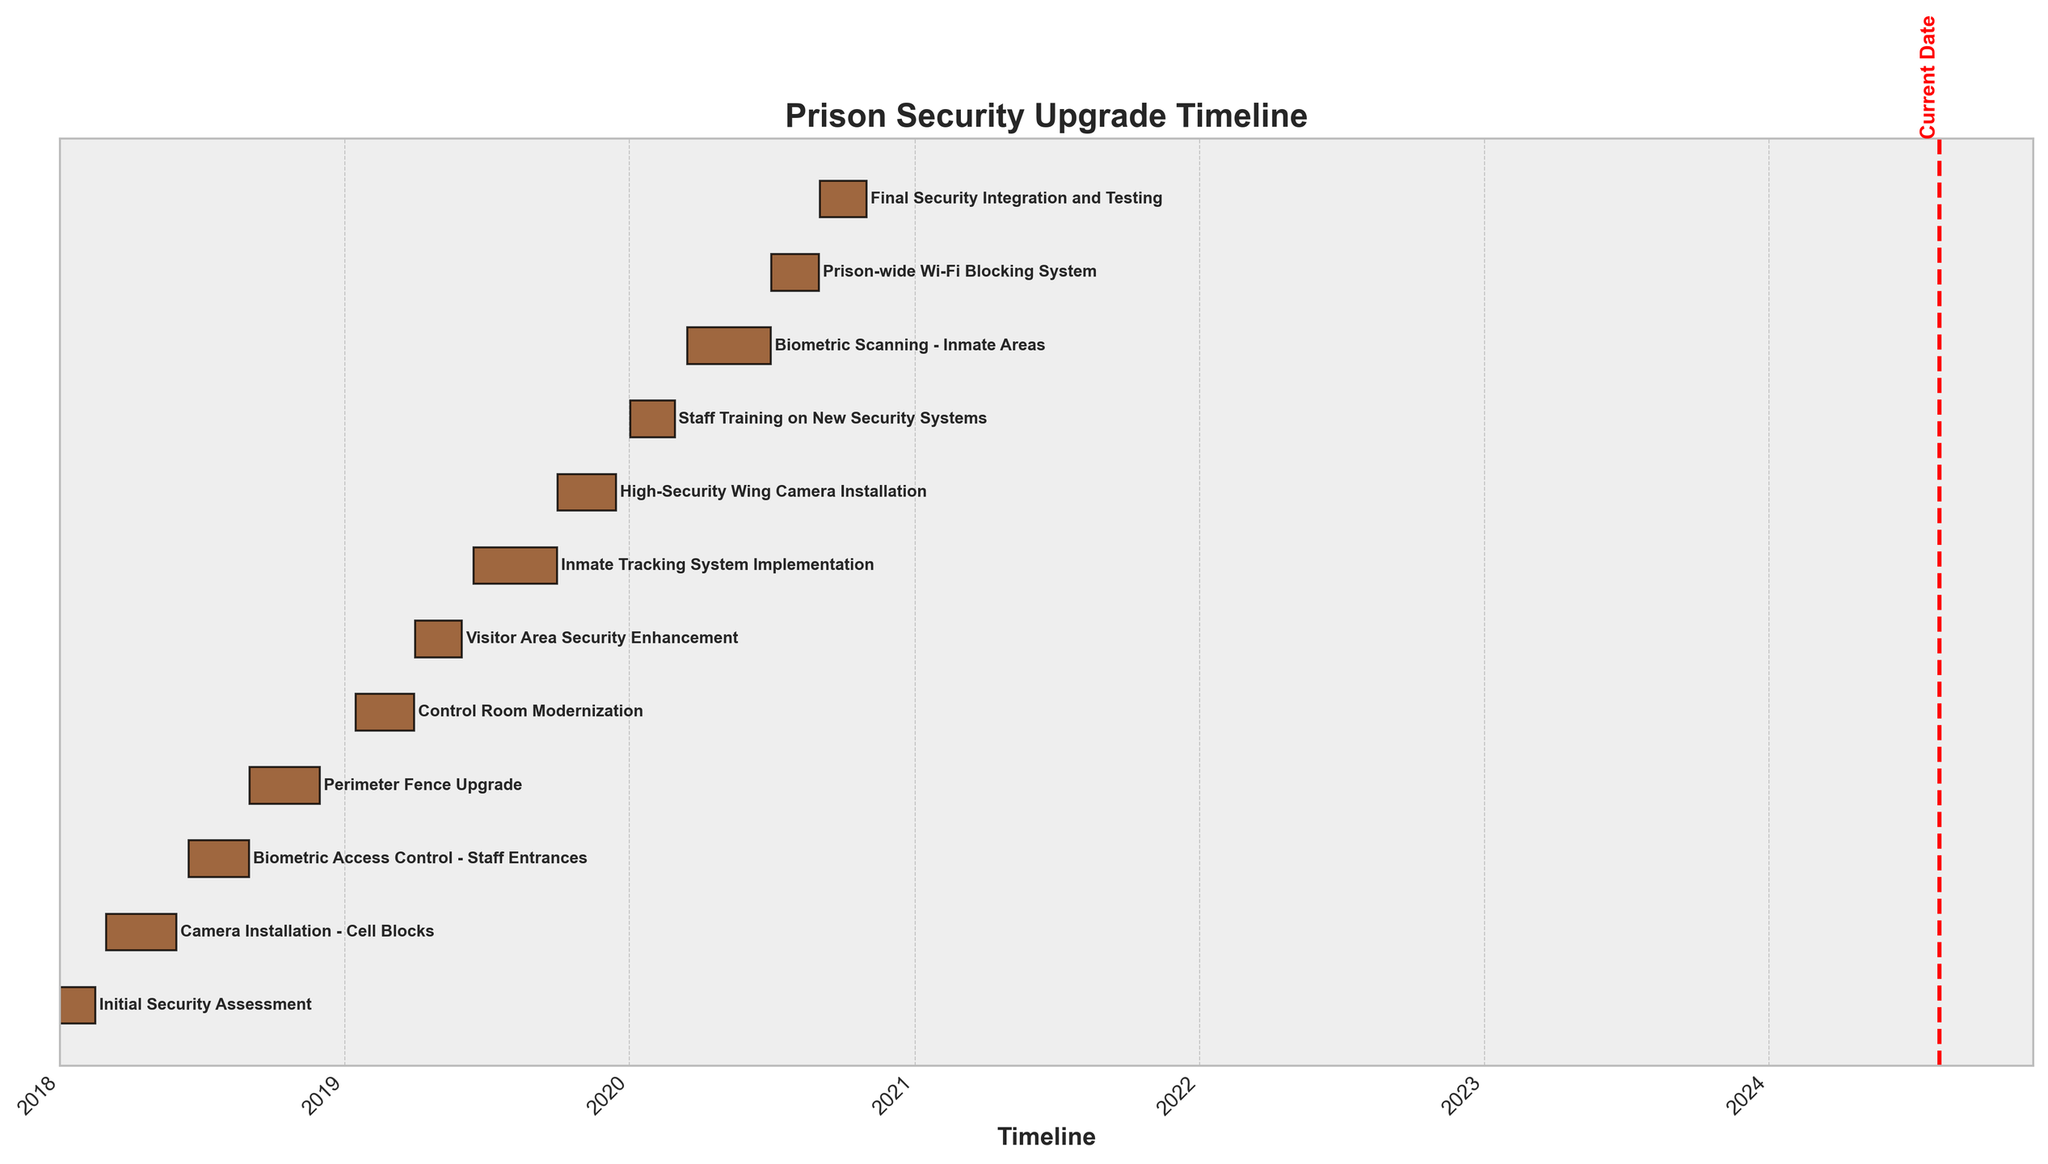What is the title of the chart? The title of the chart appears at the top and indicates the main subject of the visualized data.
Answer: Prison Security Upgrade Timeline Which task starts first in the timeline? The task that is positioned at the earliest date on the x-axis is the first task in the timeline.
Answer: Initial Security Assessment How long did the Camera Installation - Cell Blocks take? Find the starting and ending date of the "Camera Installation - Cell Blocks" bar on the y-axis. Calculate the difference between these dates.
Answer: 90 days Which security upgrade task took the longest time to complete? Compare the length of each bar to determine which task extends the longest on the x-axis.
Answer: Inmate Tracking System Implementation When did the Staff Training on New Security Systems start? Locate the "Staff Training on New Security Systems" label and check the starting date at the beginning of its corresponding bar.
Answer: 2020-01-02 What is the time gap between the end of the Biometric Access Control - Staff Entrances and the start of the Perimeter Fence Upgrade? Check the ending date of the "Biometric Access Control - Staff Entrances" and the starting date of the "Perimeter Fence Upgrade". Calculate the difference.
Answer: 15 days How many tasks were completed by the end of 2019? Identify the tasks with an end date earlier than or on 2019-12-31, then count these tasks.
Answer: 7 tasks Which task concluded before the start of 2020 but ended in the second half of 2019? Check for tasks with an end date after mid-2019 and before 2020.
Answer: High-Security Wing Camera Installation Is there an overlapping period between the Visitor Area Security Enhancement and the Control Room Modernization? Compare the start and end dates of both tasks to see if there are any common dates.
Answer: No What security task follows right after the Installation of Biometric Scanning - Inmate Areas? Identify the position of the "Biometric Scanning - Inmate Areas" bar and determine which bar starts next sequentially after its end date.
Answer: Prison-wide Wi-Fi Blocking System 